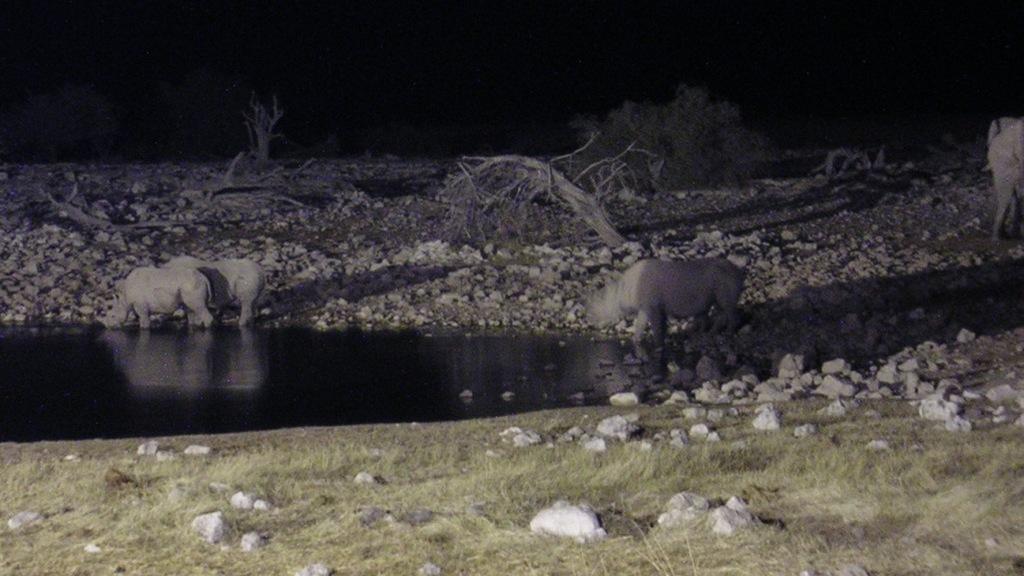Describe this image in one or two sentences. In the image there are few rhinoceros drinking water from the pond and the land is covered with stones,dry trees. 